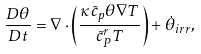<formula> <loc_0><loc_0><loc_500><loc_500>\frac { D \theta } { D t } = \nabla \cdot \left ( \frac { \kappa \tilde { c } _ { p } \theta \nabla T } { \tilde { c } _ { P } ^ { r } T } \right ) + \dot { \theta } _ { i r r } ,</formula> 